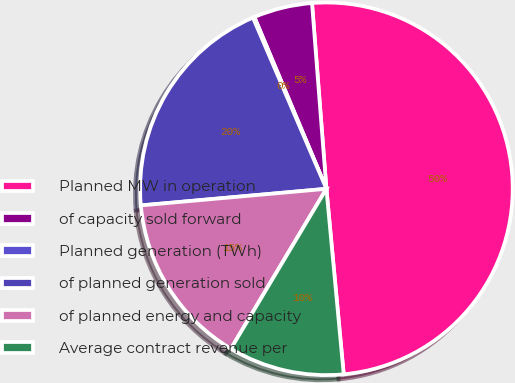Convert chart. <chart><loc_0><loc_0><loc_500><loc_500><pie_chart><fcel>Planned MW in operation<fcel>of capacity sold forward<fcel>Planned generation (TWh)<fcel>of planned generation sold<fcel>of planned energy and capacity<fcel>Average contract revenue per<nl><fcel>49.75%<fcel>5.09%<fcel>0.13%<fcel>19.97%<fcel>15.01%<fcel>10.05%<nl></chart> 